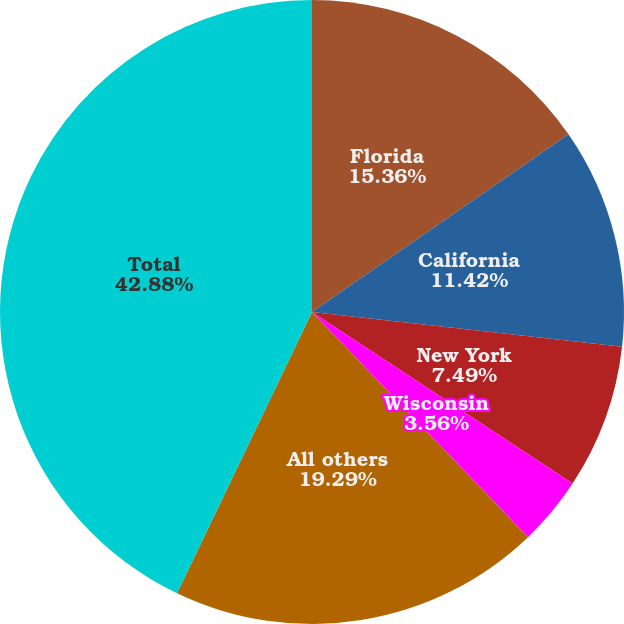Convert chart to OTSL. <chart><loc_0><loc_0><loc_500><loc_500><pie_chart><fcel>Florida<fcel>California<fcel>New York<fcel>Wisconsin<fcel>All others<fcel>Total<nl><fcel>15.36%<fcel>11.42%<fcel>7.49%<fcel>3.56%<fcel>19.29%<fcel>42.88%<nl></chart> 